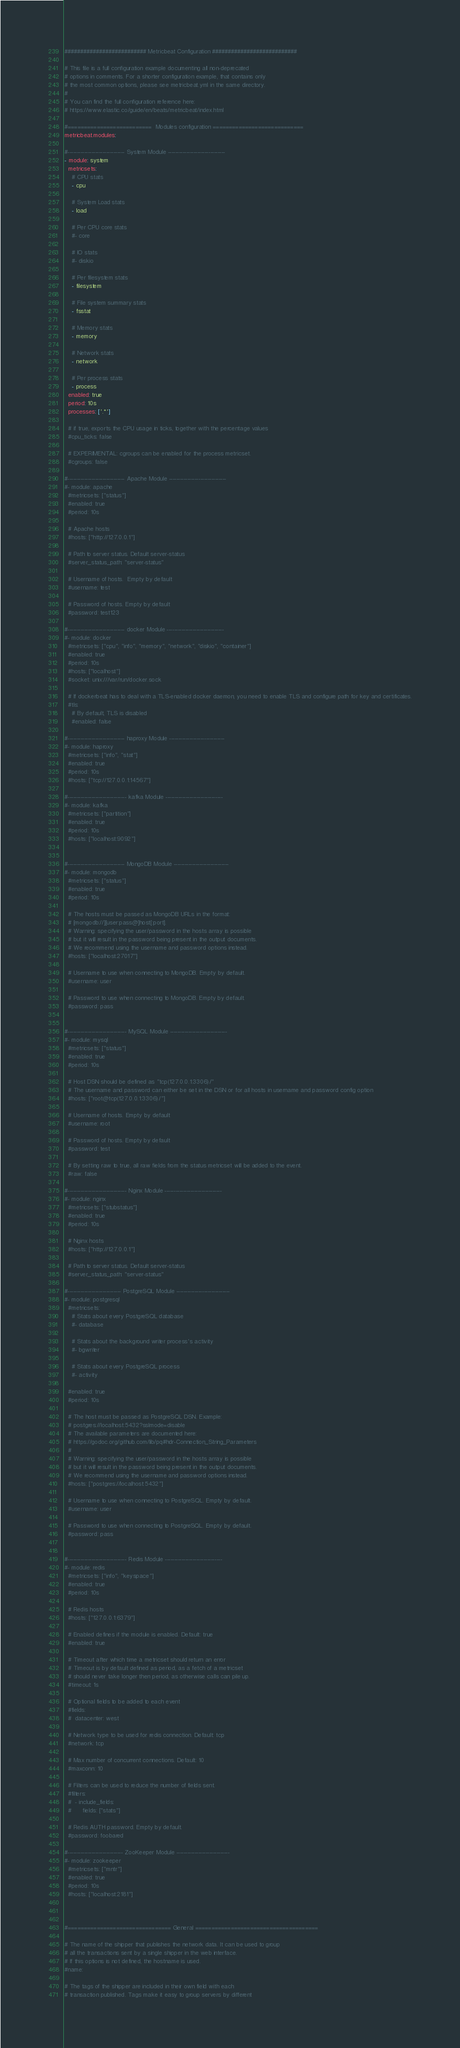Convert code to text. <code><loc_0><loc_0><loc_500><loc_500><_YAML_>########################## Metricbeat Configuration ###########################

# This file is a full configuration example documenting all non-deprecated
# options in comments. For a shorter configuration example, that contains only
# the most common options, please see metricbeat.yml in the same directory.
#
# You can find the full configuration reference here:
# https://www.elastic.co/guide/en/beats/metricbeat/index.html

#==========================  Modules configuration ============================
metricbeat.modules:

#------------------------------- System Module -------------------------------
- module: system
  metricsets:
    # CPU stats
    - cpu

    # System Load stats
    - load

    # Per CPU core stats
    #- core

    # IO stats
    #- diskio

    # Per filesystem stats
    - filesystem

    # File system summary stats
    - fsstat

    # Memory stats
    - memory

    # Network stats
    - network

    # Per process stats
    - process
  enabled: true
  period: 10s
  processes: ['.*']

  # if true, exports the CPU usage in ticks, together with the percentage values
  #cpu_ticks: false

  # EXPERIMENTAL: cgroups can be enabled for the process metricset.
  #cgroups: false

#------------------------------- Apache Module -------------------------------
#- module: apache
  #metricsets: ["status"]
  #enabled: true
  #period: 10s

  # Apache hosts
  #hosts: ["http://127.0.0.1"]

  # Path to server status. Default server-status
  #server_status_path: "server-status"

  # Username of hosts.  Empty by default
  #username: test

  # Password of hosts. Empty by default
  #password: test123

#------------------------------- docker Module -------------------------------
#- module: docker
  #metricsets: ["cpu", "info", "memory", "network", "diskio", "container"]
  #enabled: true
  #period: 10s
  #hosts: ["localhost"]
  #socket: unix:///var/run/docker.sock

  # If dockerbeat has to deal with a TLS-enabled docker daemon, you need to enable TLS and configure path for key and certificates.
  #tls:
    # By default, TLS is disabled
    #enabled: false

#------------------------------- haproxy Module ------------------------------
#- module: haproxy
  #metricsets: ["info", "stat"]
  #enabled: true
  #period: 10s
  #hosts: ["tcp://127.0.0.1:14567"]

#-------------------------------- kafka Module -------------------------------
#- module: kafka
  #metricsets: ["partition"]
  #enabled: true
  #period: 10s
  #hosts: ["localhost:9092"]


#------------------------------- MongoDB Module ------------------------------
#- module: mongodb
  #metricsets: ["status"]
  #enabled: true
  #period: 10s

  # The hosts must be passed as MongoDB URLs in the format:
  # [mongodb://][user:pass@]host[:port].
  # Warning: specifying the user/password in the hosts array is possible
  # but it will result in the password being present in the output documents.
  # We recommend using the username and password options instead.
  #hosts: ["localhost:27017"]

  # Username to use when connecting to MongoDB. Empty by default.
  #username: user

  # Password to use when connecting to MongoDB. Empty by default.
  #password: pass


#-------------------------------- MySQL Module -------------------------------
#- module: mysql
  #metricsets: ["status"]
  #enabled: true
  #period: 10s

  # Host DSN should be defined as "tcp(127.0.0.1:3306)/"
  # The username and password can either be set in the DSN or for all hosts in username and password config option
  #hosts: ["root@tcp(127.0.0.1:3306)/"]

  # Username of hosts. Empty by default
  #username: root

  # Password of hosts. Empty by default
  #password: test

  # By setting raw to true, all raw fields from the status metricset will be added to the event.
  #raw: false

#-------------------------------- Nginx Module -------------------------------
#- module: nginx
  #metricsets: ["stubstatus"]
  #enabled: true
  #period: 10s

  # Nginx hosts
  #hosts: ["http://127.0.0.1"]

  # Path to server status. Default server-status
  #server_status_path: "server-status"

#----------------------------- PostgreSQL Module -----------------------------
#- module: postgresql
  #metricsets:
    # Stats about every PostgreSQL database
    #- database

    # Stats about the background writer process's activity
    #- bgwriter

    # Stats about every PostgreSQL process
    #- activity

  #enabled: true
  #period: 10s

  # The host must be passed as PostgreSQL DSN. Example:
  # postgres://localhost:5432?sslmode=disable
  # The available parameters are documented here:
  # https://godoc.org/github.com/lib/pq#hdr-Connection_String_Parameters
  #
  # Warning: specifying the user/password in the hosts array is possible
  # but it will result in the password being present in the output documents.
  # We recommend using the username and password options instead.
  #hosts: ["postgres://localhost:5432"]

  # Username to use when connecting to PostgreSQL. Empty by default.
  #username: user

  # Password to use when connecting to PostgreSQL. Empty by default.
  #password: pass


#-------------------------------- Redis Module -------------------------------
#- module: redis
  #metricsets: ["info", "keyspace"]
  #enabled: true
  #period: 10s

  # Redis hosts
  #hosts: ["127.0.0.1:6379"]

  # Enabled defines if the module is enabled. Default: true
  #enabled: true

  # Timeout after which time a metricset should return an error
  # Timeout is by default defined as period, as a fetch of a metricset
  # should never take longer then period, as otherwise calls can pile up.
  #timeout: 1s

  # Optional fields to be added to each event
  #fields:
  #  datacenter: west

  # Network type to be used for redis connection. Default: tcp
  #network: tcp

  # Max number of concurrent connections. Default: 10
  #maxconn: 10

  # Filters can be used to reduce the number of fields sent.
  #filters:
  #  - include_fields:
  #      fields: ["stats"]

  # Redis AUTH password. Empty by default.
  #password: foobared

#------------------------------ ZooKeeper Module -----------------------------
#- module: zookeeper
  #metricsets: ["mntr"]
  #enabled: true
  #period: 10s
  #hosts: ["localhost:2181"]



#================================ General ======================================

# The name of the shipper that publishes the network data. It can be used to group
# all the transactions sent by a single shipper in the web interface.
# If this options is not defined, the hostname is used.
#name:

# The tags of the shipper are included in their own field with each
# transaction published. Tags make it easy to group servers by different</code> 